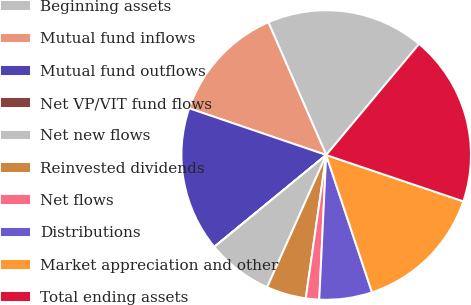Convert chart. <chart><loc_0><loc_0><loc_500><loc_500><pie_chart><fcel>Beginning assets<fcel>Mutual fund inflows<fcel>Mutual fund outflows<fcel>Net VP/VIT fund flows<fcel>Net new flows<fcel>Reinvested dividends<fcel>Net flows<fcel>Distributions<fcel>Market appreciation and other<fcel>Total ending assets<nl><fcel>17.63%<fcel>13.23%<fcel>16.16%<fcel>0.02%<fcel>7.36%<fcel>4.43%<fcel>1.49%<fcel>5.89%<fcel>14.69%<fcel>19.1%<nl></chart> 